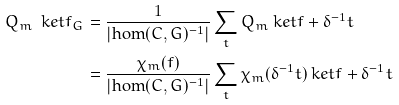Convert formula to latex. <formula><loc_0><loc_0><loc_500><loc_500>Q _ { m } \ k e t { f _ { G } } & = \frac { 1 } { | \text {hom} ( C , G ) ^ { - 1 } | } \sum _ { t } Q _ { m } \ k e t { f + \delta ^ { - 1 } t } \\ & = \frac { \chi _ { m } ( f ) } { | \text {hom} ( C , G ) ^ { - 1 } | } \sum _ { t } \chi _ { m } ( \delta ^ { - 1 } t ) \ k e t { f + \delta ^ { - 1 } t }</formula> 